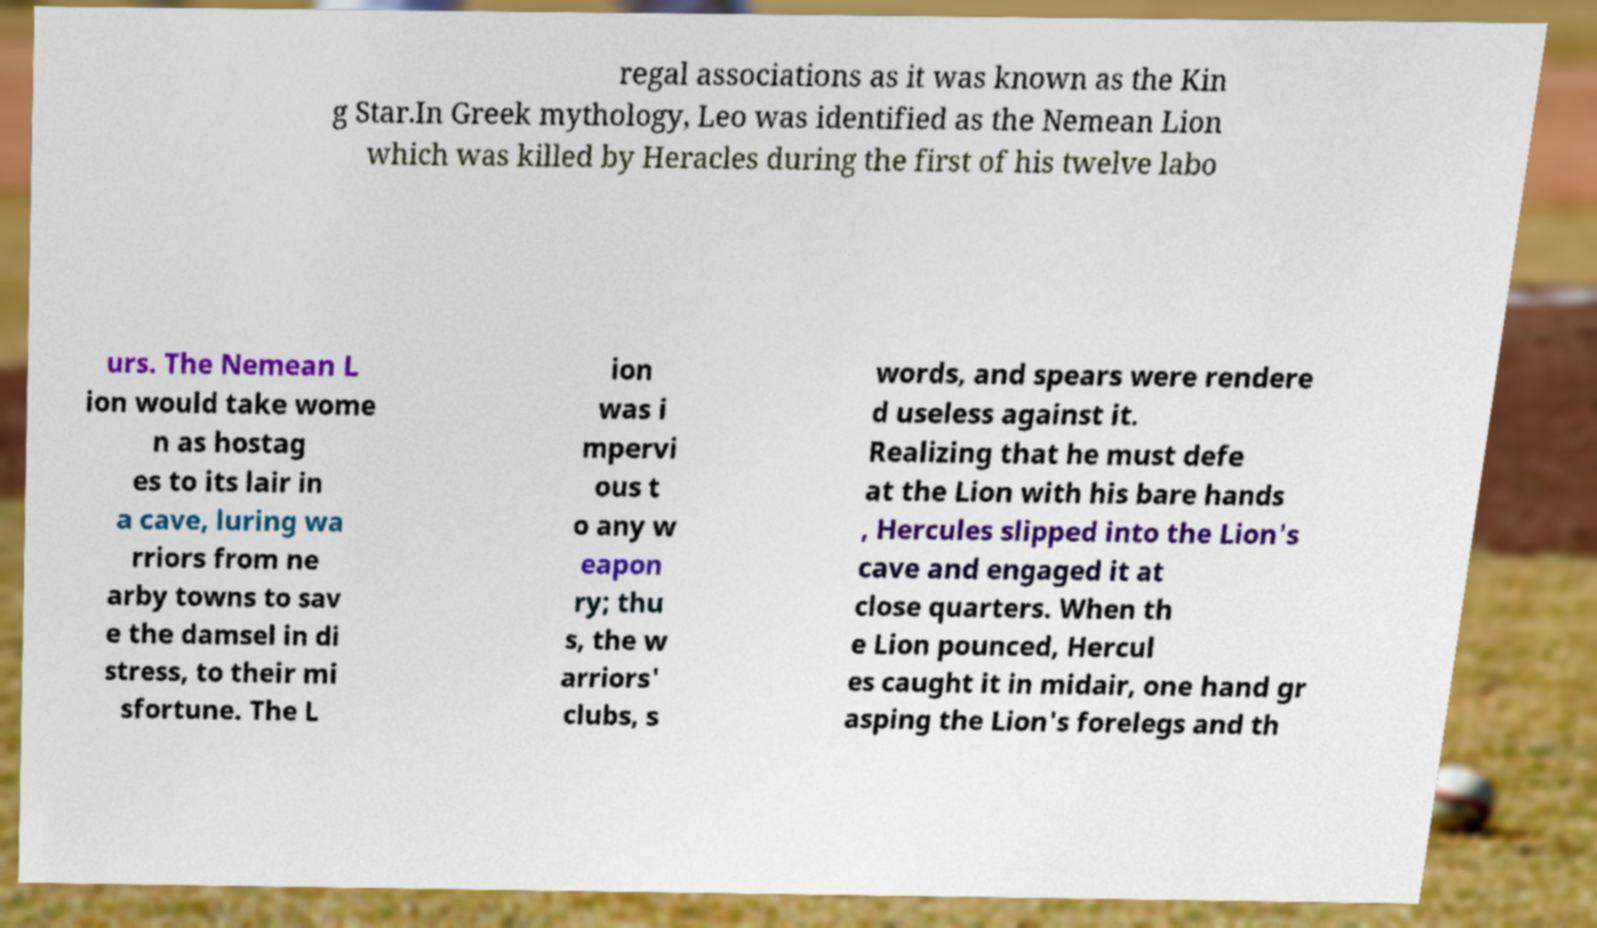There's text embedded in this image that I need extracted. Can you transcribe it verbatim? regal associations as it was known as the Kin g Star.In Greek mythology, Leo was identified as the Nemean Lion which was killed by Heracles during the first of his twelve labo urs. The Nemean L ion would take wome n as hostag es to its lair in a cave, luring wa rriors from ne arby towns to sav e the damsel in di stress, to their mi sfortune. The L ion was i mpervi ous t o any w eapon ry; thu s, the w arriors' clubs, s words, and spears were rendere d useless against it. Realizing that he must defe at the Lion with his bare hands , Hercules slipped into the Lion's cave and engaged it at close quarters. When th e Lion pounced, Hercul es caught it in midair, one hand gr asping the Lion's forelegs and th 